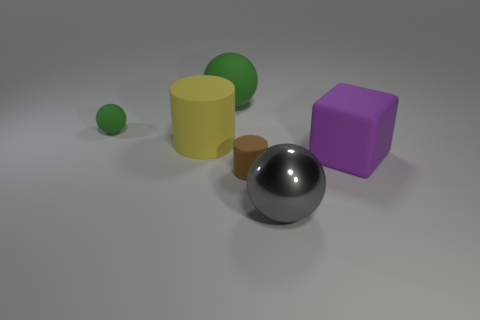Add 1 large metallic objects. How many objects exist? 7 Subtract all blocks. How many objects are left? 5 Subtract all tiny cylinders. Subtract all big green spheres. How many objects are left? 4 Add 5 yellow matte things. How many yellow matte things are left? 6 Add 6 gray matte blocks. How many gray matte blocks exist? 6 Subtract 1 gray spheres. How many objects are left? 5 